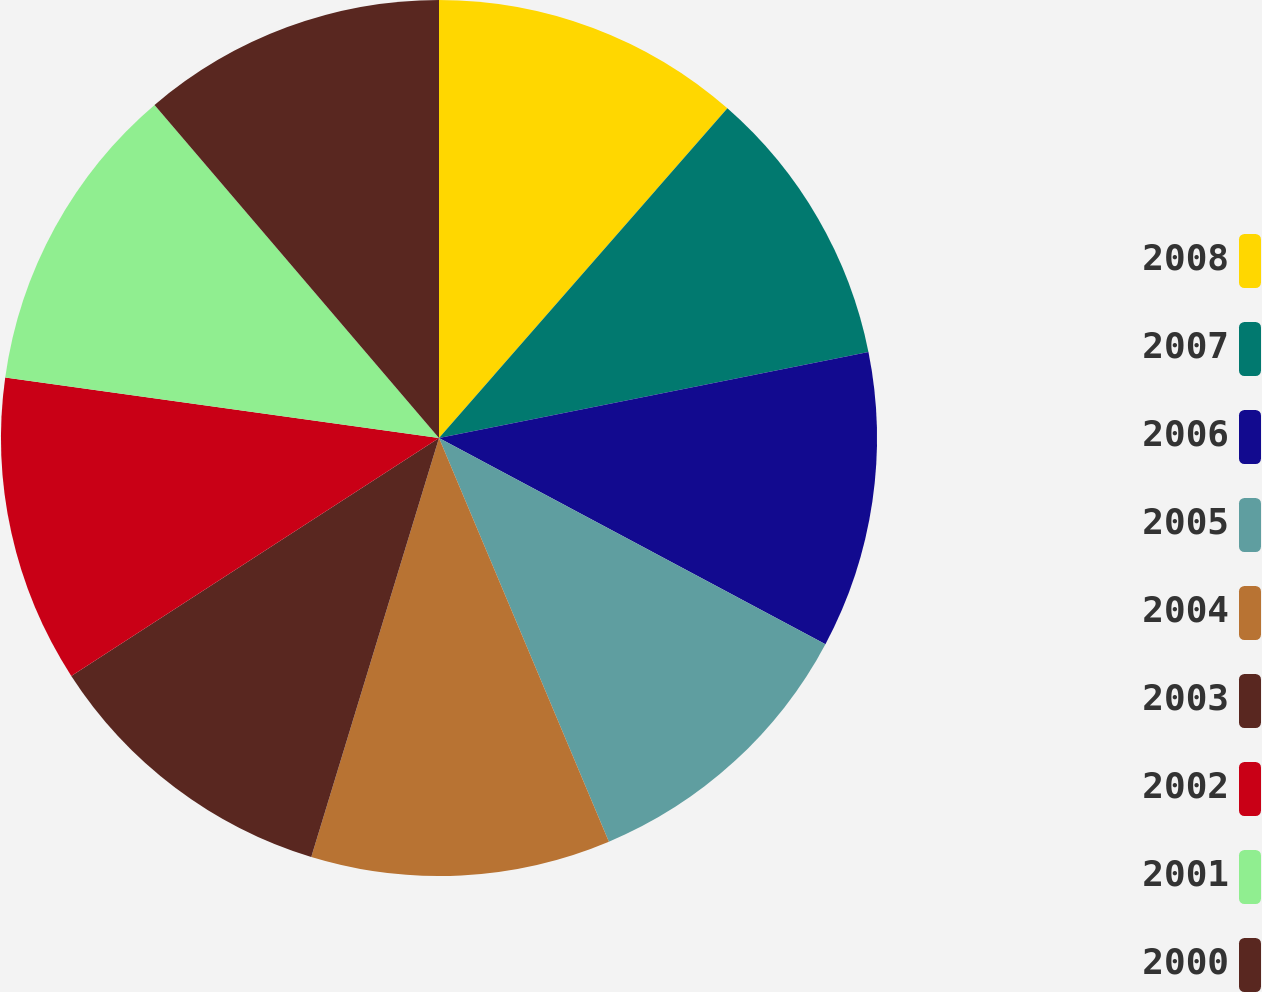Convert chart to OTSL. <chart><loc_0><loc_0><loc_500><loc_500><pie_chart><fcel>2008<fcel>2007<fcel>2006<fcel>2005<fcel>2004<fcel>2003<fcel>2002<fcel>2001<fcel>2000<nl><fcel>11.44%<fcel>10.41%<fcel>10.95%<fcel>10.86%<fcel>11.05%<fcel>11.15%<fcel>11.35%<fcel>11.54%<fcel>11.25%<nl></chart> 